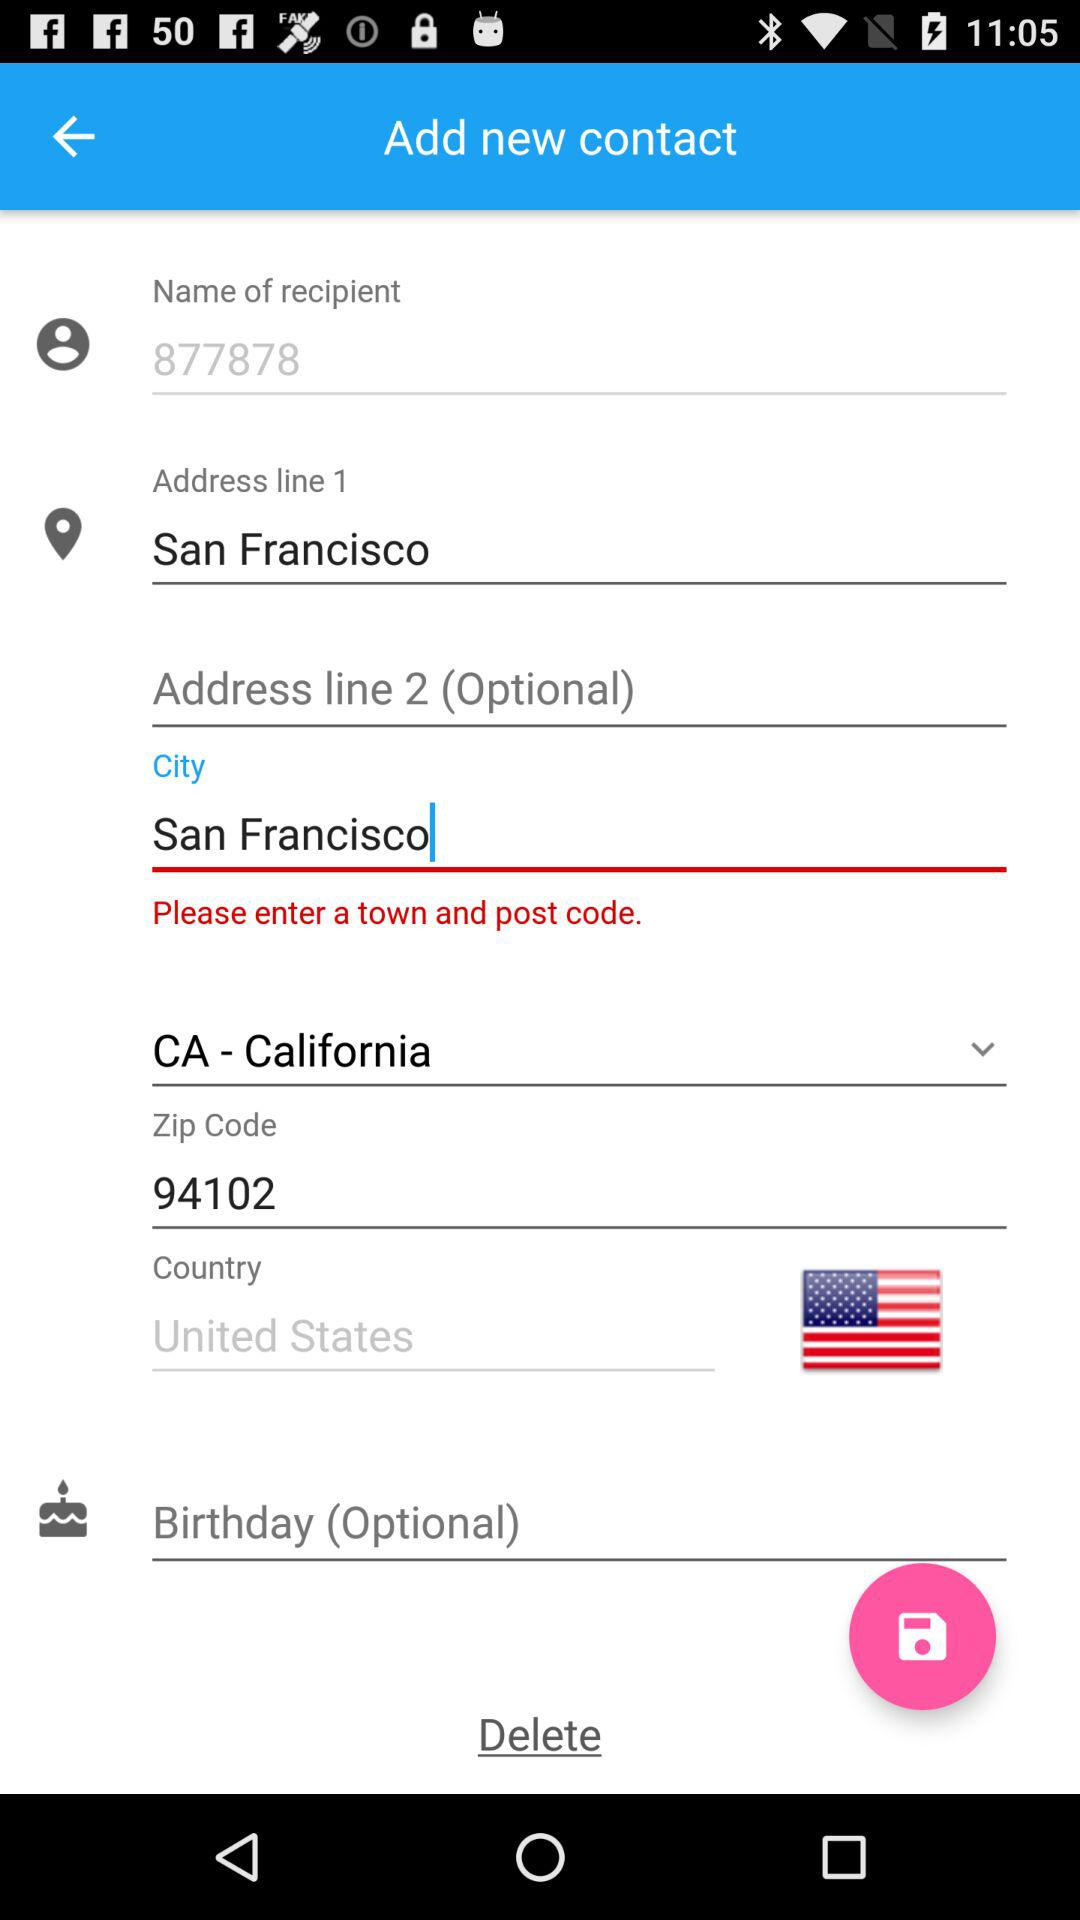Which city was mentioned? The mentioned city was San Francisco. 